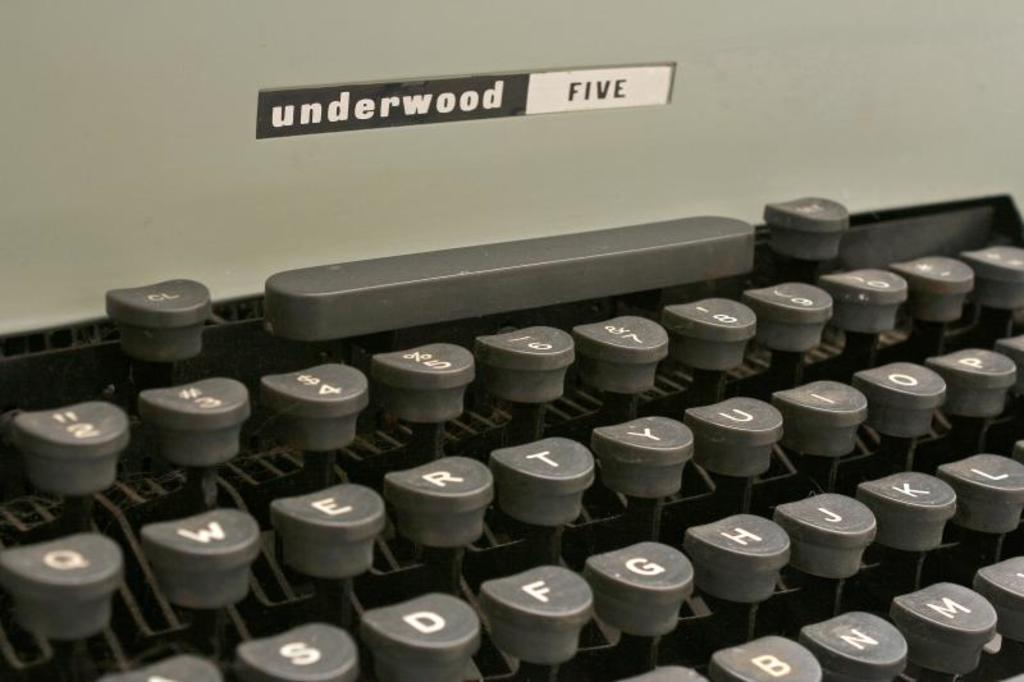<image>
Present a compact description of the photo's key features. An Underwood Five typewriter has the number keys above the letter keys. 